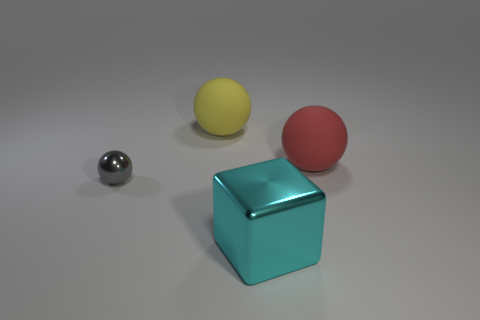What is the shape of the thing in front of the sphere that is in front of the red rubber thing?
Keep it short and to the point. Cube. What number of other objects are there of the same shape as the small metallic thing?
Offer a very short reply. 2. What is the size of the object that is left of the large rubber ball that is on the left side of the large red rubber thing?
Provide a short and direct response. Small. Are any tiny green blocks visible?
Offer a very short reply. No. How many cyan objects are behind the large thing that is in front of the small object?
Your answer should be compact. 0. There is a matte thing left of the cyan object; what shape is it?
Give a very brief answer. Sphere. There is a large ball that is in front of the large sphere that is left of the matte object right of the big metallic block; what is its material?
Provide a short and direct response. Rubber. How many other objects are the same size as the red rubber sphere?
Your response must be concise. 2. There is a large red object that is the same shape as the big yellow thing; what is its material?
Your response must be concise. Rubber. What is the color of the big cube?
Keep it short and to the point. Cyan. 